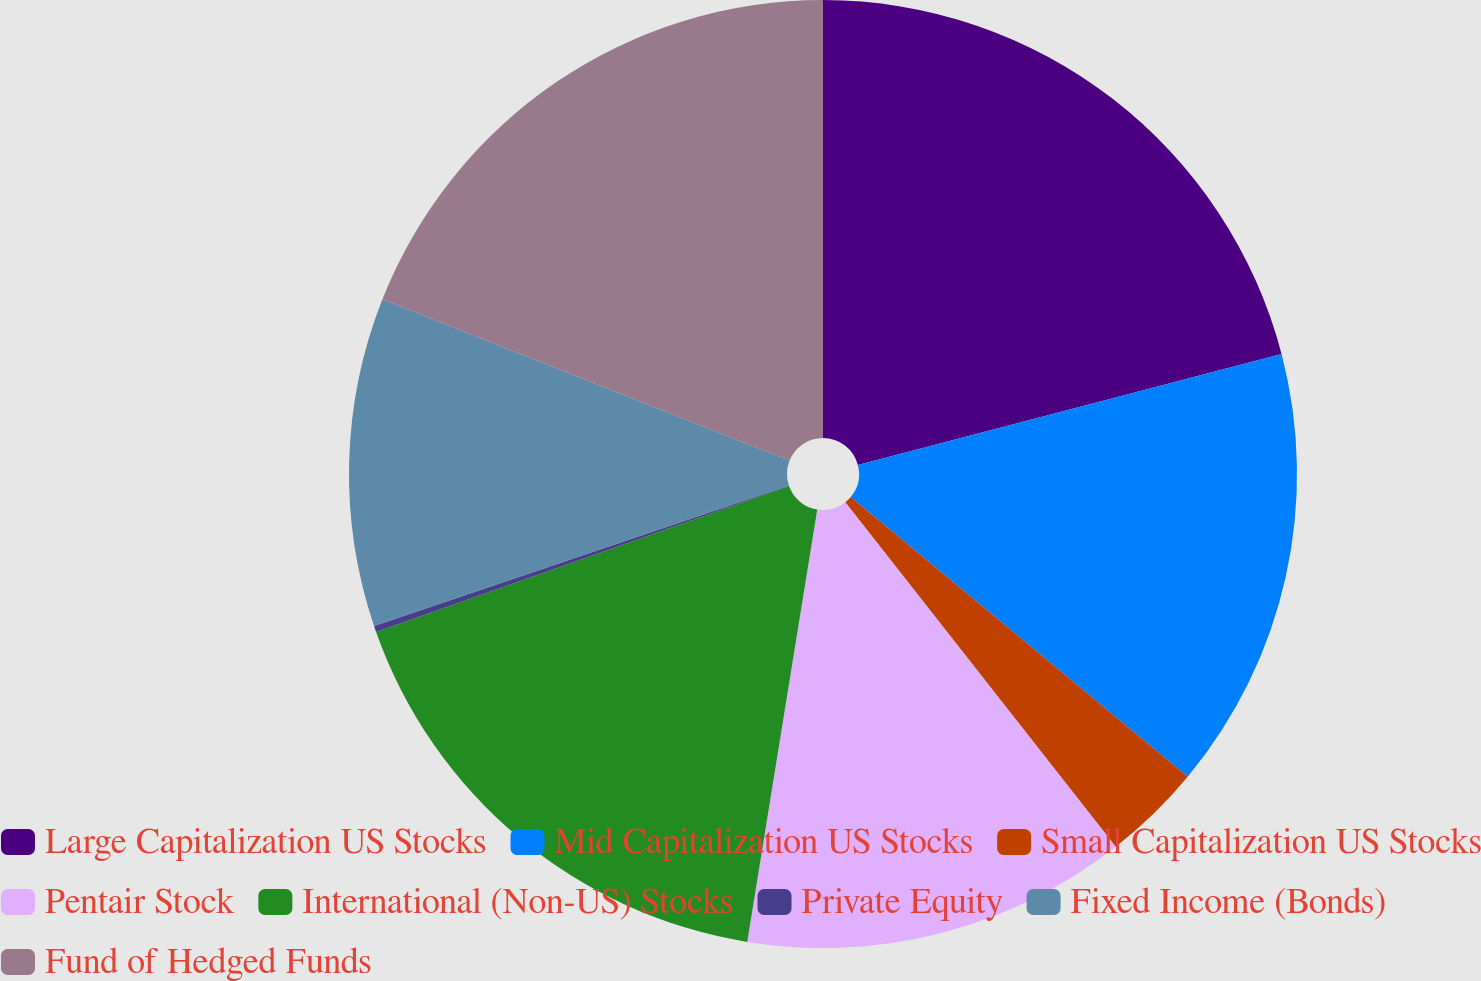Convert chart. <chart><loc_0><loc_0><loc_500><loc_500><pie_chart><fcel>Large Capitalization US Stocks<fcel>Mid Capitalization US Stocks<fcel>Small Capitalization US Stocks<fcel>Pentair Stock<fcel>International (Non-US) Stocks<fcel>Private Equity<fcel>Fixed Income (Bonds)<fcel>Fund of Hedged Funds<nl><fcel>20.93%<fcel>15.1%<fcel>3.38%<fcel>13.15%<fcel>17.04%<fcel>0.21%<fcel>11.21%<fcel>18.99%<nl></chart> 